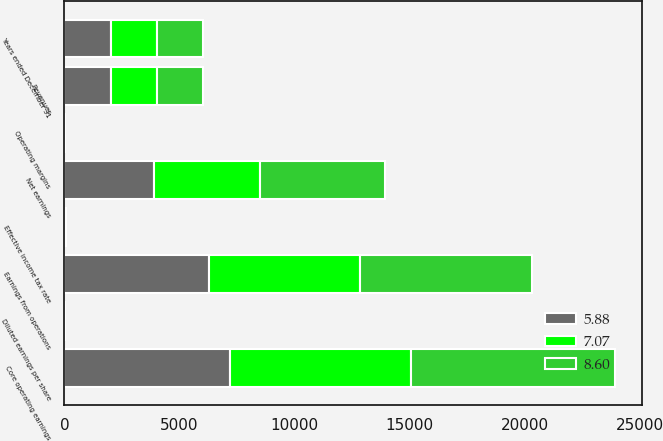Convert chart to OTSL. <chart><loc_0><loc_0><loc_500><loc_500><stacked_bar_chart><ecel><fcel>Years ended December 31<fcel>Revenues<fcel>Earnings from operations<fcel>Operating margins<fcel>Effective income tax rate<fcel>Net earnings<fcel>Diluted earnings per share<fcel>Core operating earnings<nl><fcel>8.6<fcel>2014<fcel>2013<fcel>7473<fcel>8.2<fcel>23.7<fcel>5446<fcel>7.38<fcel>8860<nl><fcel>7.07<fcel>2013<fcel>2013<fcel>6562<fcel>7.6<fcel>26.4<fcel>4585<fcel>5.96<fcel>7876<nl><fcel>5.88<fcel>2012<fcel>2013<fcel>6290<fcel>7.7<fcel>34<fcel>3900<fcel>5.11<fcel>7189<nl></chart> 